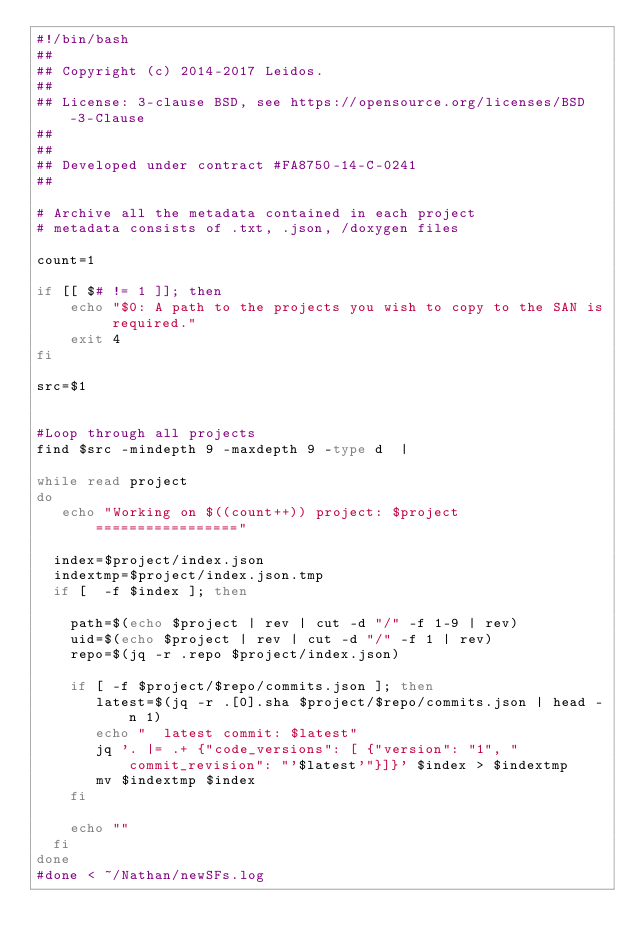Convert code to text. <code><loc_0><loc_0><loc_500><loc_500><_Bash_>#!/bin/bash
##
## Copyright (c) 2014-2017 Leidos.
## 
## License: 3-clause BSD, see https://opensource.org/licenses/BSD-3-Clause
##
##
## Developed under contract #FA8750-14-C-0241
##

# Archive all the metadata contained in each project
# metadata consists of .txt, .json, /doxygen files 

count=1

if [[ $# != 1 ]]; then
    echo "$0: A path to the projects you wish to copy to the SAN is required."
    exit 4
fi

src=$1


#Loop through all projects
find $src -mindepth 9 -maxdepth 9 -type d  |

while read project
do
   echo "Working on $((count++)) project: $project ================="

  index=$project/index.json
  indextmp=$project/index.json.tmp
  if [  -f $index ]; then

    path=$(echo $project | rev | cut -d "/" -f 1-9 | rev)
    uid=$(echo $project | rev | cut -d "/" -f 1 | rev)
    repo=$(jq -r .repo $project/index.json)

    if [ -f $project/$repo/commits.json ]; then
       latest=$(jq -r .[0].sha $project/$repo/commits.json | head -n 1)
       echo "  latest commit: $latest"
       jq '. |= .+ {"code_versions": [ {"version": "1", "commit_revision": "'$latest'"}]}' $index > $indextmp
       mv $indextmp $index
    fi

    echo ""
  fi
done
#done < ~/Nathan/newSFs.log

</code> 